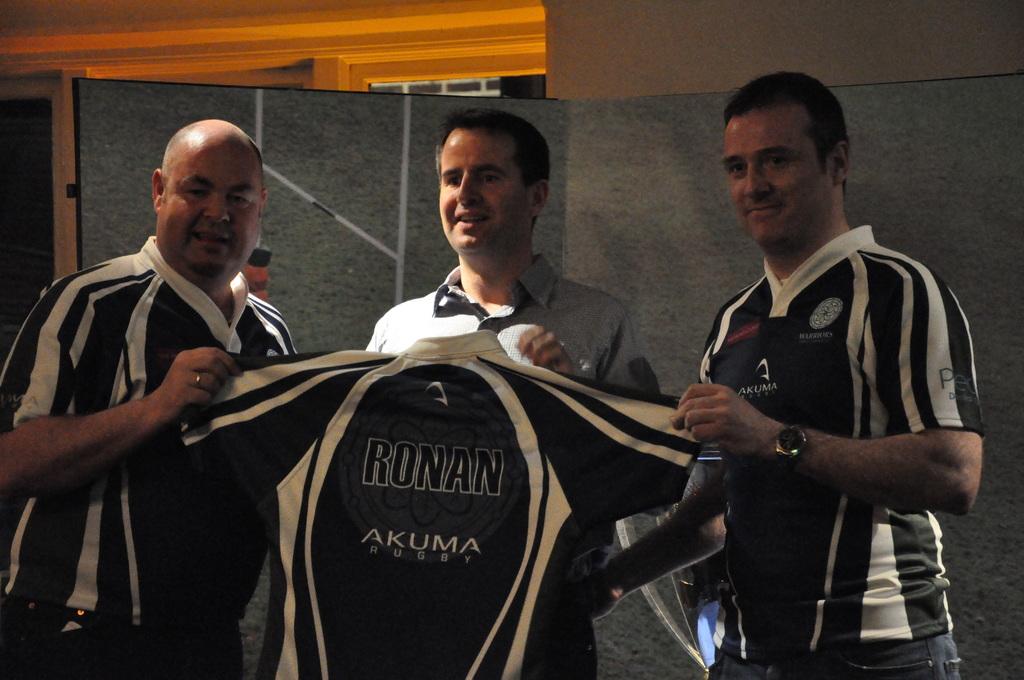What sport is written on the jersey?
Offer a terse response. Rugby. 